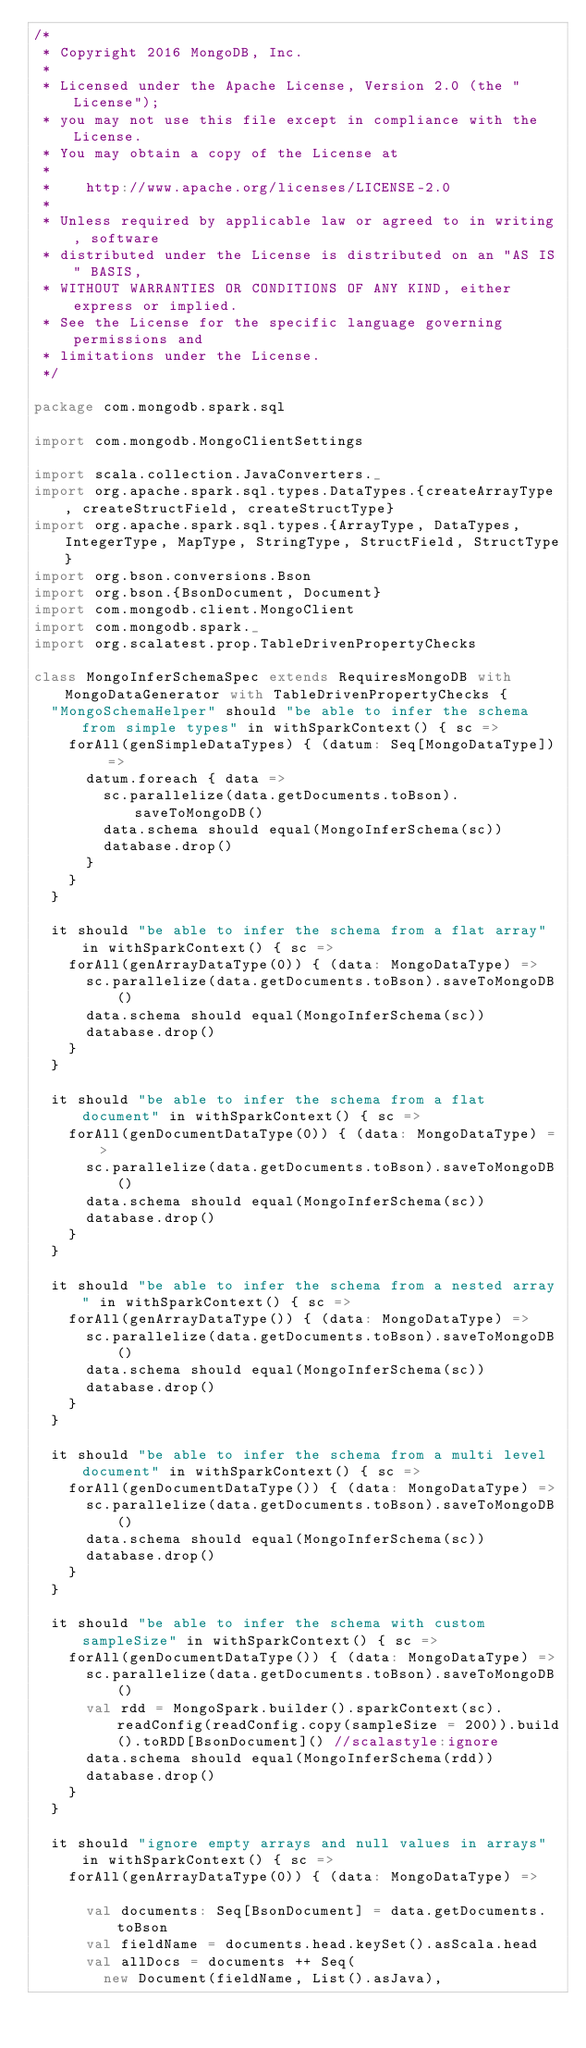<code> <loc_0><loc_0><loc_500><loc_500><_Scala_>/*
 * Copyright 2016 MongoDB, Inc.
 *
 * Licensed under the Apache License, Version 2.0 (the "License");
 * you may not use this file except in compliance with the License.
 * You may obtain a copy of the License at
 *
 *    http://www.apache.org/licenses/LICENSE-2.0
 *
 * Unless required by applicable law or agreed to in writing, software
 * distributed under the License is distributed on an "AS IS" BASIS,
 * WITHOUT WARRANTIES OR CONDITIONS OF ANY KIND, either express or implied.
 * See the License for the specific language governing permissions and
 * limitations under the License.
 */

package com.mongodb.spark.sql

import com.mongodb.MongoClientSettings

import scala.collection.JavaConverters._
import org.apache.spark.sql.types.DataTypes.{createArrayType, createStructField, createStructType}
import org.apache.spark.sql.types.{ArrayType, DataTypes, IntegerType, MapType, StringType, StructField, StructType}
import org.bson.conversions.Bson
import org.bson.{BsonDocument, Document}
import com.mongodb.client.MongoClient
import com.mongodb.spark._
import org.scalatest.prop.TableDrivenPropertyChecks

class MongoInferSchemaSpec extends RequiresMongoDB with MongoDataGenerator with TableDrivenPropertyChecks {
  "MongoSchemaHelper" should "be able to infer the schema from simple types" in withSparkContext() { sc =>
    forAll(genSimpleDataTypes) { (datum: Seq[MongoDataType]) =>
      datum.foreach { data =>
        sc.parallelize(data.getDocuments.toBson).saveToMongoDB()
        data.schema should equal(MongoInferSchema(sc))
        database.drop()
      }
    }
  }

  it should "be able to infer the schema from a flat array" in withSparkContext() { sc =>
    forAll(genArrayDataType(0)) { (data: MongoDataType) =>
      sc.parallelize(data.getDocuments.toBson).saveToMongoDB()
      data.schema should equal(MongoInferSchema(sc))
      database.drop()
    }
  }

  it should "be able to infer the schema from a flat document" in withSparkContext() { sc =>
    forAll(genDocumentDataType(0)) { (data: MongoDataType) =>
      sc.parallelize(data.getDocuments.toBson).saveToMongoDB()
      data.schema should equal(MongoInferSchema(sc))
      database.drop()
    }
  }

  it should "be able to infer the schema from a nested array" in withSparkContext() { sc =>
    forAll(genArrayDataType()) { (data: MongoDataType) =>
      sc.parallelize(data.getDocuments.toBson).saveToMongoDB()
      data.schema should equal(MongoInferSchema(sc))
      database.drop()
    }
  }

  it should "be able to infer the schema from a multi level document" in withSparkContext() { sc =>
    forAll(genDocumentDataType()) { (data: MongoDataType) =>
      sc.parallelize(data.getDocuments.toBson).saveToMongoDB()
      data.schema should equal(MongoInferSchema(sc))
      database.drop()
    }
  }

  it should "be able to infer the schema with custom sampleSize" in withSparkContext() { sc =>
    forAll(genDocumentDataType()) { (data: MongoDataType) =>
      sc.parallelize(data.getDocuments.toBson).saveToMongoDB()
      val rdd = MongoSpark.builder().sparkContext(sc).readConfig(readConfig.copy(sampleSize = 200)).build().toRDD[BsonDocument]() //scalastyle:ignore
      data.schema should equal(MongoInferSchema(rdd))
      database.drop()
    }
  }

  it should "ignore empty arrays and null values in arrays" in withSparkContext() { sc =>
    forAll(genArrayDataType(0)) { (data: MongoDataType) =>

      val documents: Seq[BsonDocument] = data.getDocuments.toBson
      val fieldName = documents.head.keySet().asScala.head
      val allDocs = documents ++ Seq(
        new Document(fieldName, List().asJava),</code> 